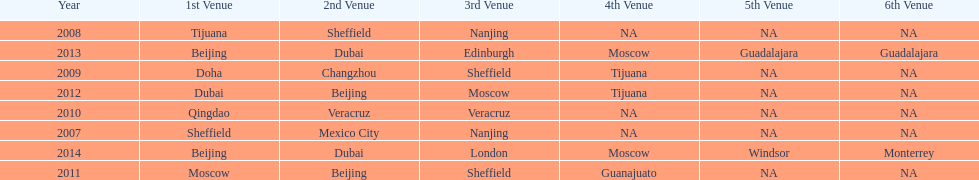In what year was the 3rd venue the same as 2011's 1st venue? 2012. 